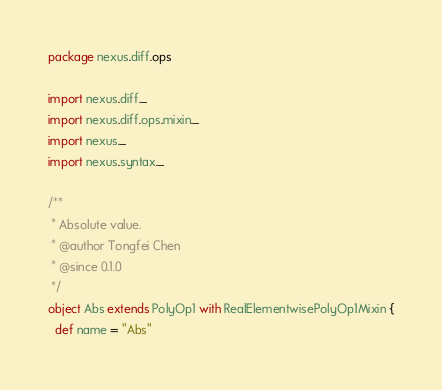Convert code to text. <code><loc_0><loc_0><loc_500><loc_500><_Scala_>package nexus.diff.ops

import nexus.diff._
import nexus.diff.ops.mixin._
import nexus._
import nexus.syntax._

/**
 * Absolute value.
 * @author Tongfei Chen
 * @since 0.1.0
 */
object Abs extends PolyOp1 with RealElementwisePolyOp1Mixin {
  def name = "Abs"</code> 